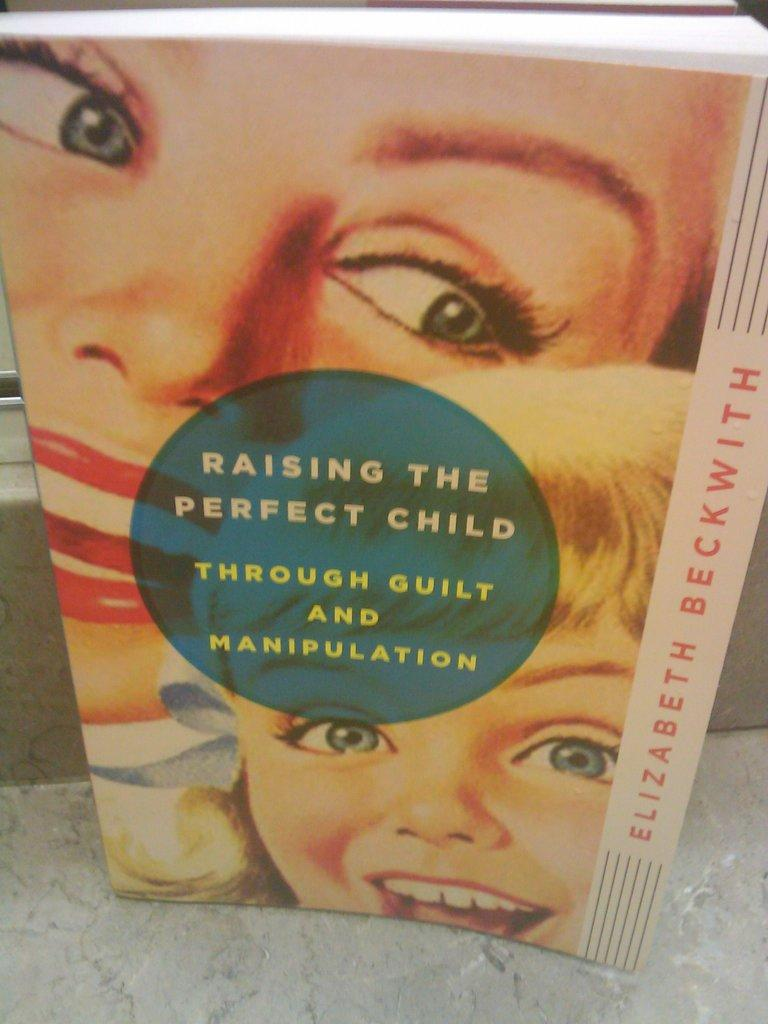What object can be seen in the image? There is a book in the image. Where is the book located? The book is on the floor. What is depicted on the cover page of the book? The cover page of the book has two people printed on it. Are there any words on the cover page of the book? Yes, the cover page of the book has text on it. What type of lettuce is being used as a bookmark in the image? There is no lettuce present in the image, and the book does not have a bookmark. 